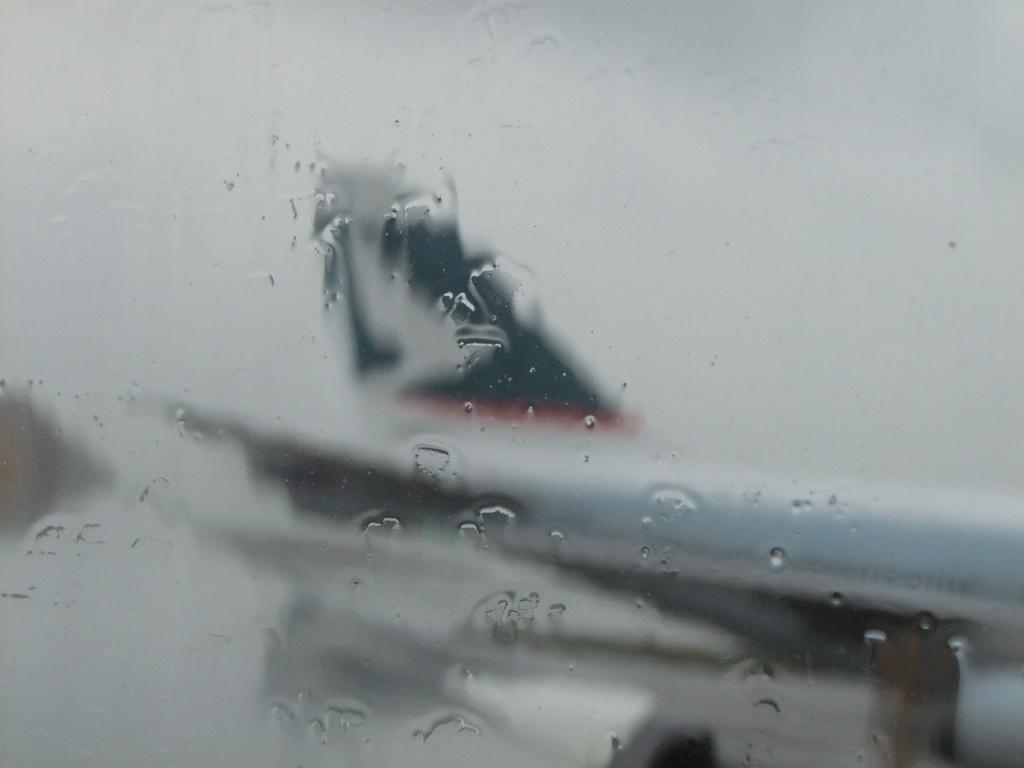Could you give a brief overview of what you see in this image? It seems like an aeroplane reflection on the mirror. 